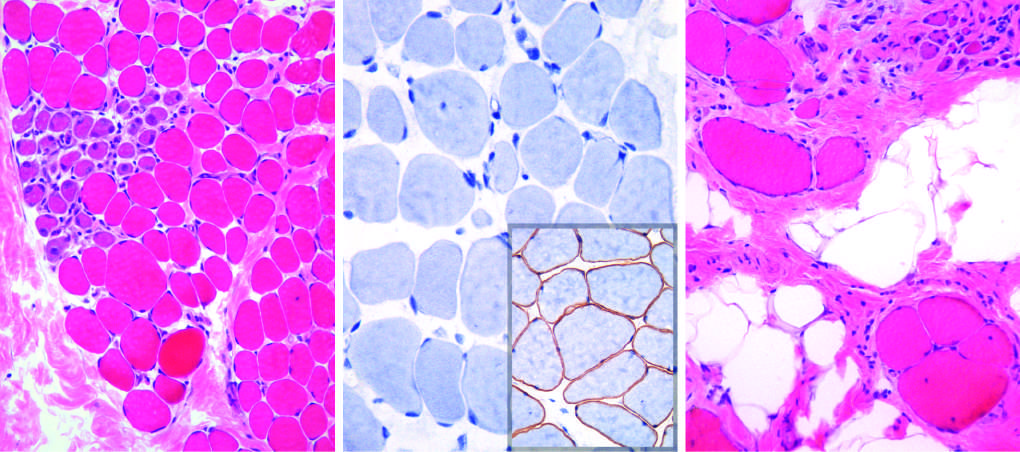s a brown stain in normal muscle seen?
Answer the question using a single word or phrase. Yes 